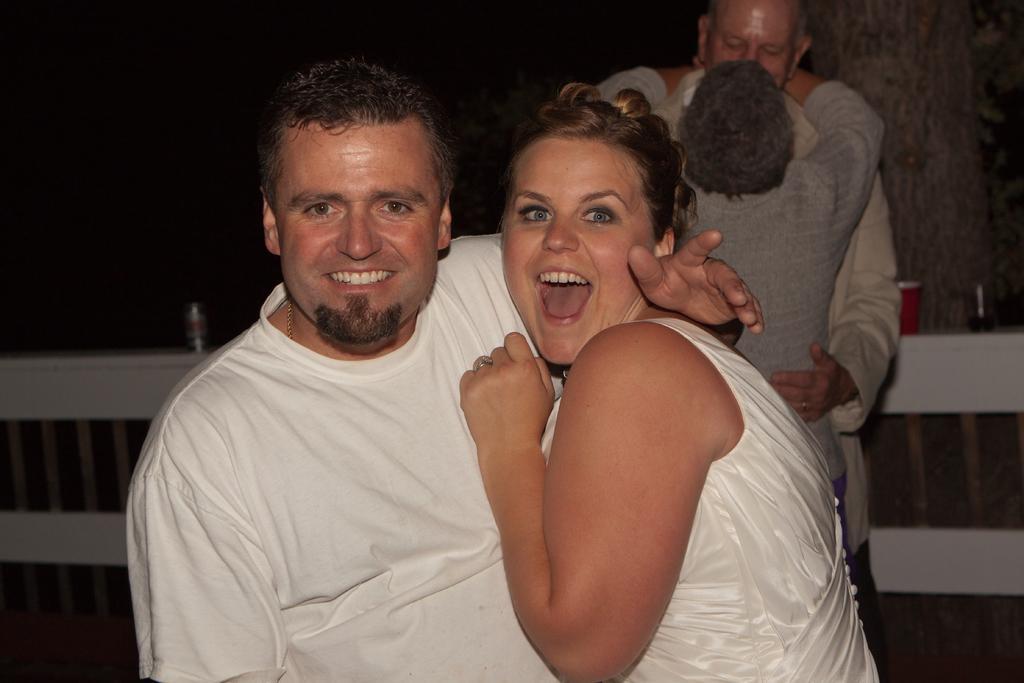Describe this image in one or two sentences. In this picture we can see a man and a woman are smiling in the front, there are two more persons in the middle, we can see a dark background. 